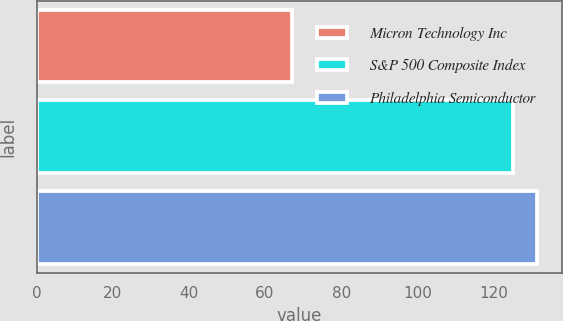Convert chart to OTSL. <chart><loc_0><loc_0><loc_500><loc_500><bar_chart><fcel>Micron Technology Inc<fcel>S&P 500 Composite Index<fcel>Philadelphia Semiconductor<nl><fcel>67<fcel>125<fcel>131.3<nl></chart> 